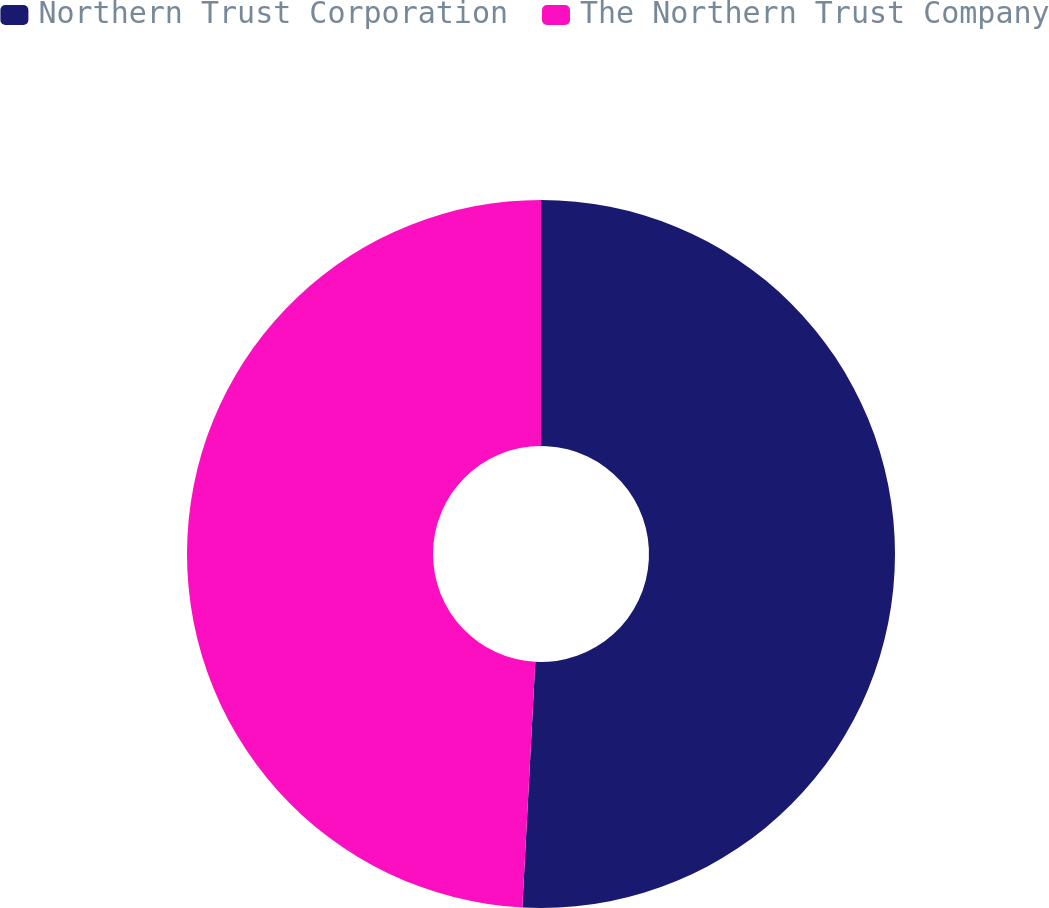<chart> <loc_0><loc_0><loc_500><loc_500><pie_chart><fcel>Northern Trust Corporation<fcel>The Northern Trust Company<nl><fcel>50.84%<fcel>49.16%<nl></chart> 